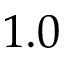<formula> <loc_0><loc_0><loc_500><loc_500>1 . 0</formula> 